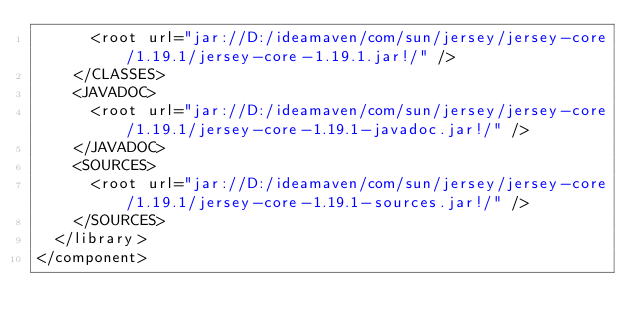<code> <loc_0><loc_0><loc_500><loc_500><_XML_>      <root url="jar://D:/ideamaven/com/sun/jersey/jersey-core/1.19.1/jersey-core-1.19.1.jar!/" />
    </CLASSES>
    <JAVADOC>
      <root url="jar://D:/ideamaven/com/sun/jersey/jersey-core/1.19.1/jersey-core-1.19.1-javadoc.jar!/" />
    </JAVADOC>
    <SOURCES>
      <root url="jar://D:/ideamaven/com/sun/jersey/jersey-core/1.19.1/jersey-core-1.19.1-sources.jar!/" />
    </SOURCES>
  </library>
</component></code> 